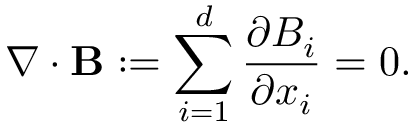<formula> <loc_0><loc_0><loc_500><loc_500>\nabla \cdot B \colon = \sum _ { i = 1 } ^ { d } \frac { \partial B _ { i } } { \partial x _ { i } } = 0 .</formula> 